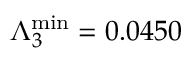<formula> <loc_0><loc_0><loc_500><loc_500>\Lambda _ { 3 } ^ { \min } = 0 . 0 4 5 0</formula> 